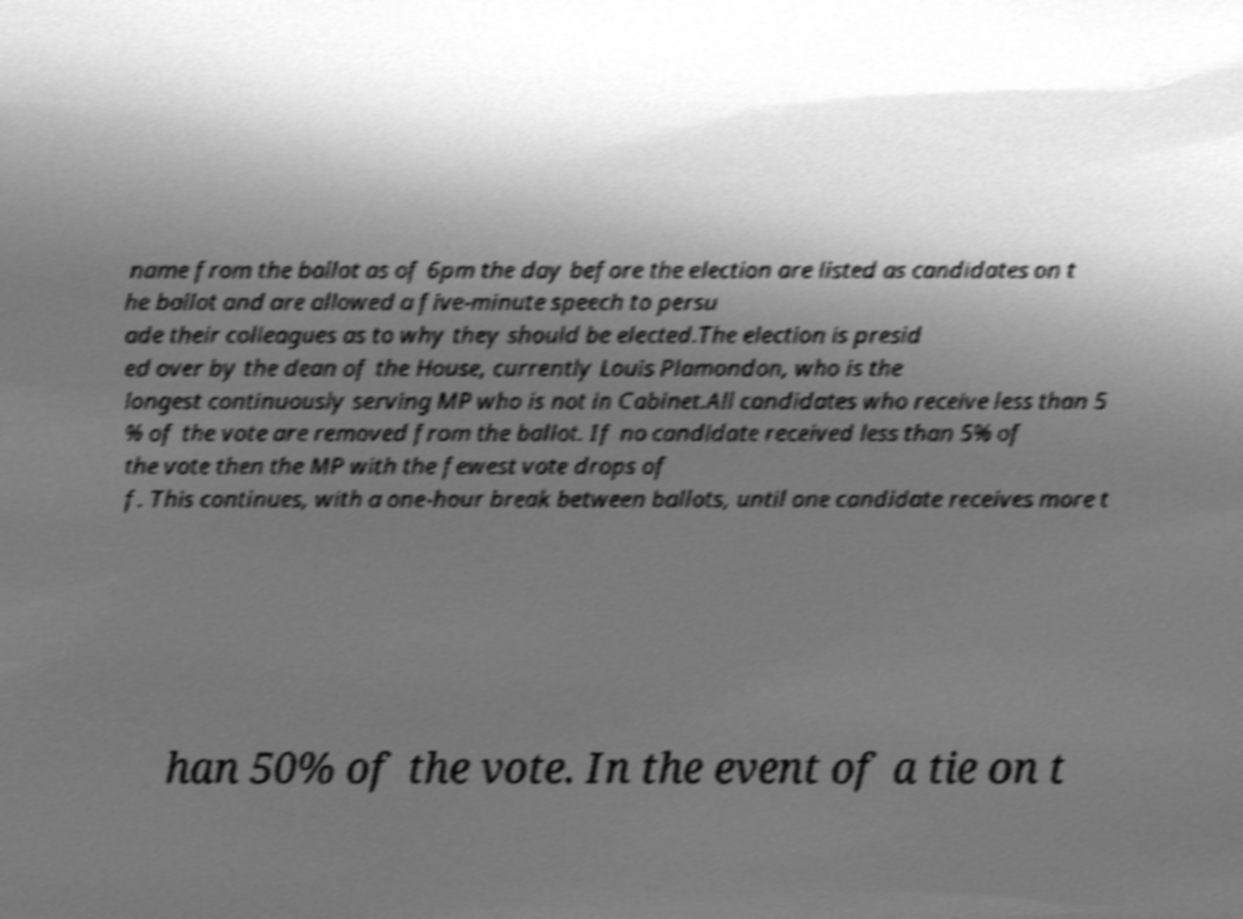Could you assist in decoding the text presented in this image and type it out clearly? name from the ballot as of 6pm the day before the election are listed as candidates on t he ballot and are allowed a five-minute speech to persu ade their colleagues as to why they should be elected.The election is presid ed over by the dean of the House, currently Louis Plamondon, who is the longest continuously serving MP who is not in Cabinet.All candidates who receive less than 5 % of the vote are removed from the ballot. If no candidate received less than 5% of the vote then the MP with the fewest vote drops of f. This continues, with a one-hour break between ballots, until one candidate receives more t han 50% of the vote. In the event of a tie on t 